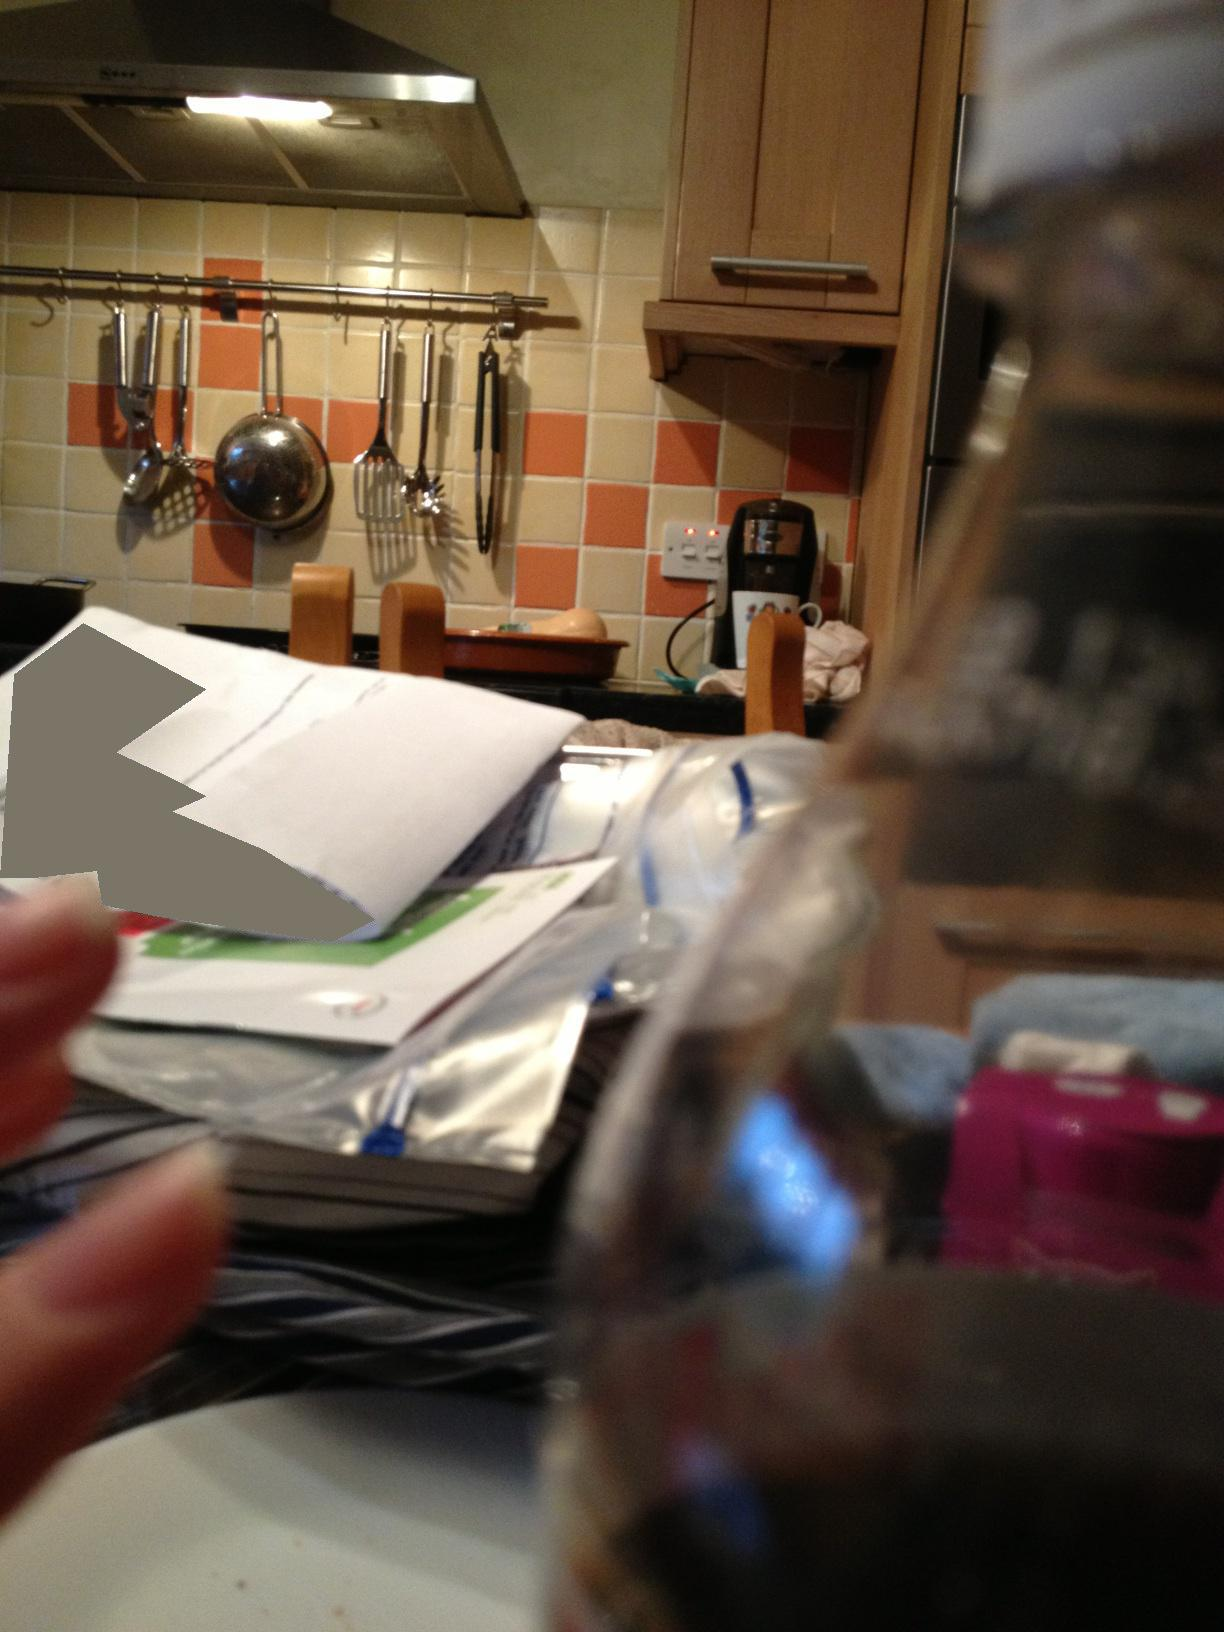Can you describe what's on the kitchen counter? The kitchen counter seems cluttered with various items including envelopes, papers, a clear plastic bag, and behind them, a wooden chopping board is visible. It reflects the everyday use of the space, with the items perhaps waiting to be sorted or used. 